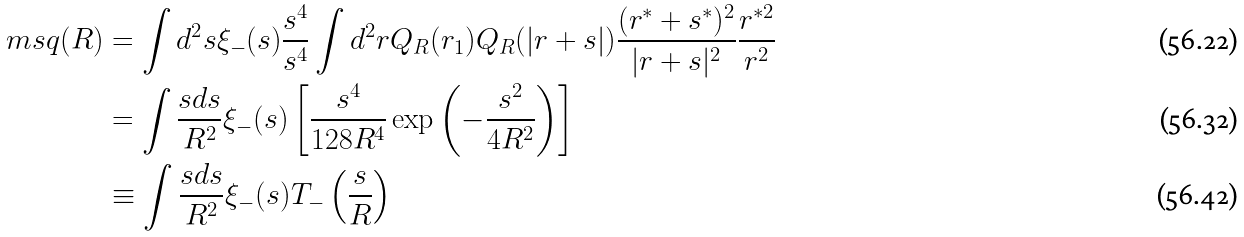Convert formula to latex. <formula><loc_0><loc_0><loc_500><loc_500>\ m s q ( R ) & = \int d ^ { 2 } s \xi _ { - } ( s ) \frac { s ^ { 4 } } { s ^ { 4 } } \int d ^ { 2 } r Q _ { R } ( r _ { 1 } ) Q _ { R } ( | r + s | ) \frac { ( r ^ { * } + s ^ { * } ) ^ { 2 } } { | r + s | ^ { 2 } } \frac { r ^ { * 2 } } { r ^ { 2 } } \\ & = \int \frac { s d s } { R ^ { 2 } } \xi _ { - } ( s ) \left [ \frac { s ^ { 4 } } { 1 2 8 R ^ { 4 } } \exp \left ( - \frac { s ^ { 2 } } { 4 R ^ { 2 } } \right ) \right ] \\ & \equiv \int \frac { s d s } { R ^ { 2 } } \xi _ { - } ( s ) T _ { - } \left ( \frac { s } { R } \right )</formula> 